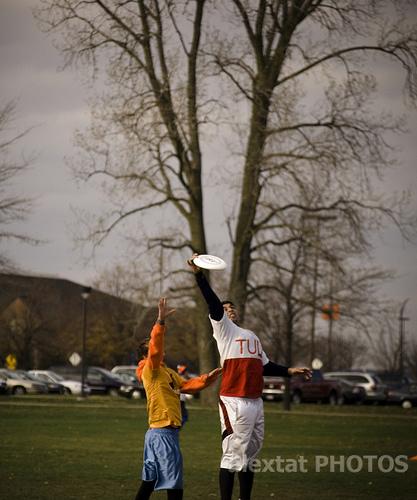What color is the Frisbee?
Answer briefly. White. What game are they playing?
Quick response, please. Frisbee. How many people are in the picture?
Give a very brief answer. 2. 